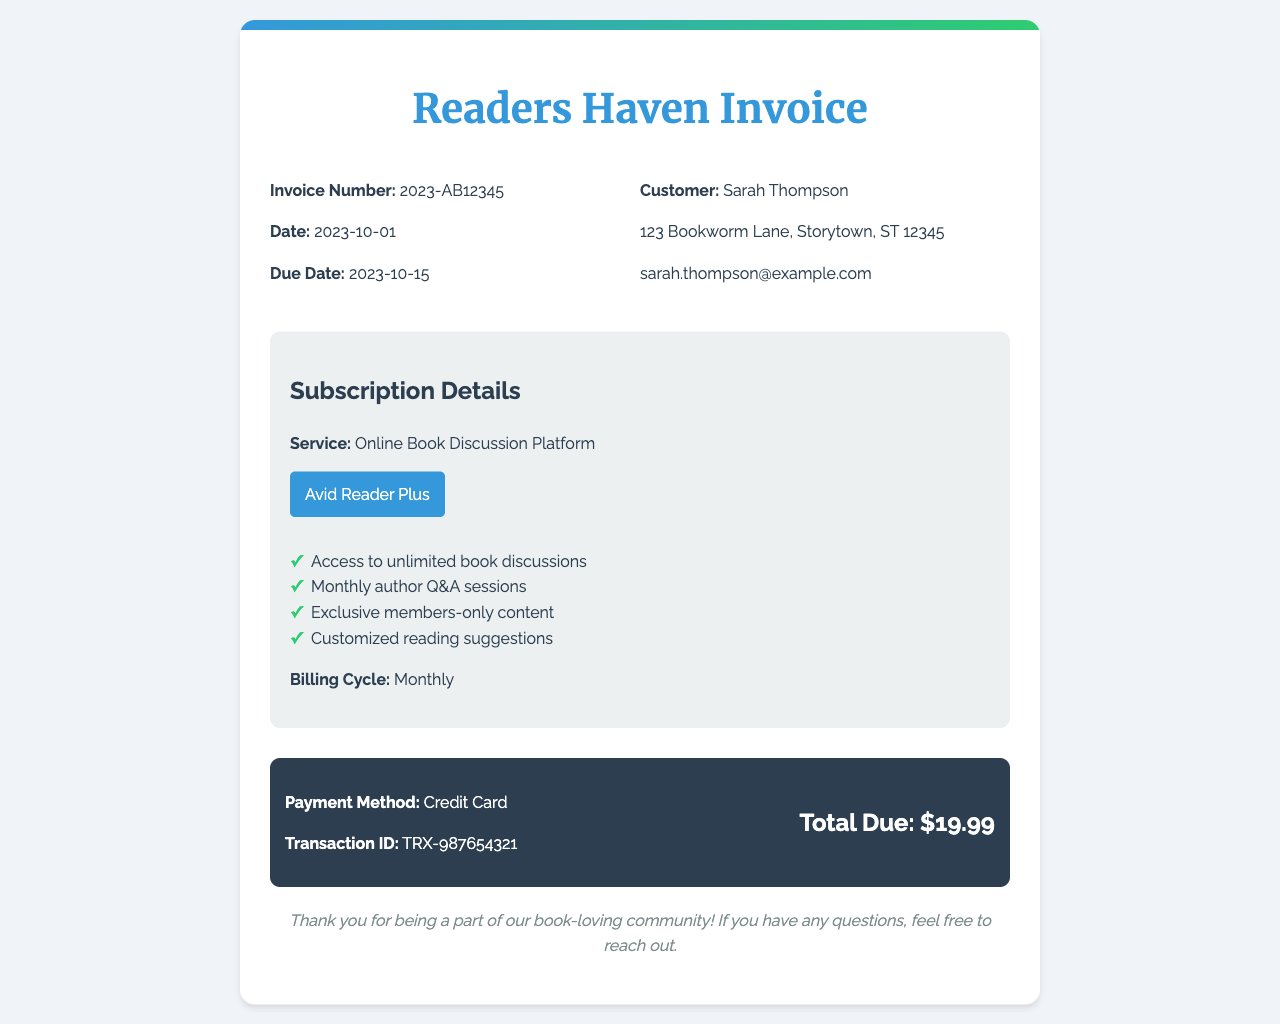What is the invoice number? The invoice number is a unique identifier found at the top of the document.
Answer: 2023-AB12345 What is the customer's name? The customer's name is provided in the billing information section.
Answer: Sarah Thompson What is the total due amount? The total due amount is specified in the payment information section.
Answer: $19.99 What is the billing cycle for the subscription? The billing cycle is mentioned in the subscription details.
Answer: Monthly Which subscription tier is selected? The subscription tier is indicated as a highlighted term in the subscription details.
Answer: Avid Reader Plus What features are included in the subscription? The features list outlines the benefits of the subscription.
Answer: Unlimited book discussions, Monthly author Q&A sessions, Exclusive members-only content, Customized reading suggestions When is the due date for the invoice? The due date can be found in the invoice header.
Answer: 2023-10-15 What is the payment method used? The payment method is specified in the payment information section.
Answer: Credit Card What is the transaction ID? The transaction ID is a unique reference number provided in the payment details.
Answer: TRX-987654321 